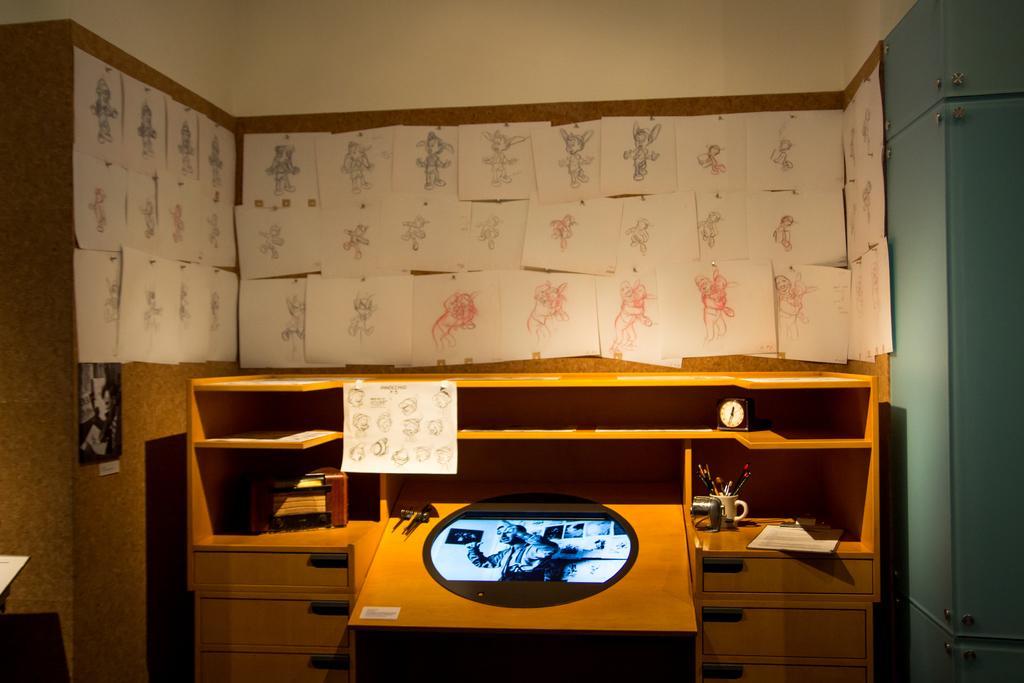How would you summarize this image in a sentence or two? In this image there is a wooden table. On top of it there are some objects. In the background of the image there are posters on the wall. 